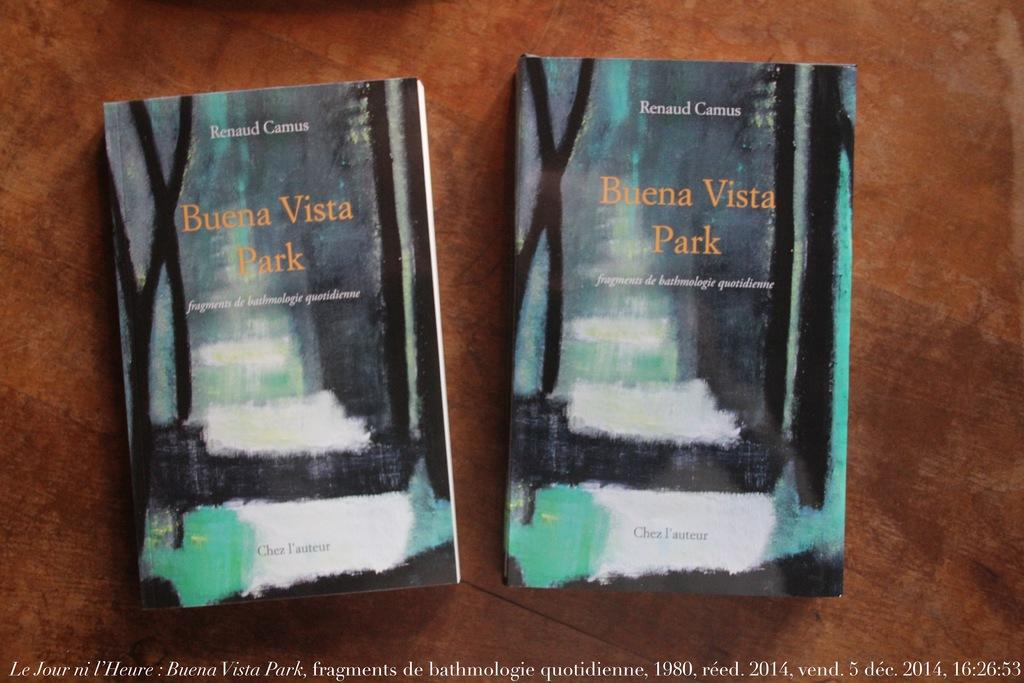<image>
Create a compact narrative representing the image presented. Two copies of the book Buena Vista park sit next to one another on a table. 